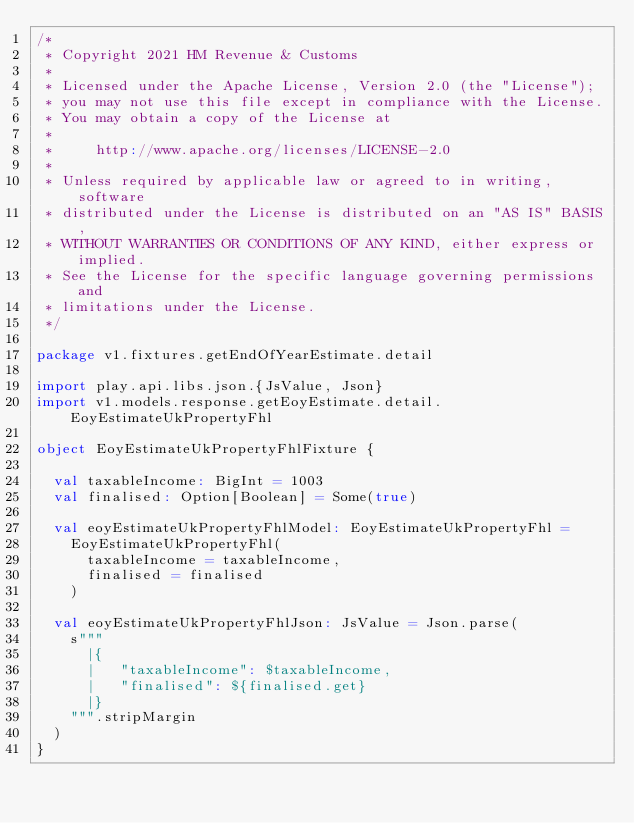Convert code to text. <code><loc_0><loc_0><loc_500><loc_500><_Scala_>/*
 * Copyright 2021 HM Revenue & Customs
 *
 * Licensed under the Apache License, Version 2.0 (the "License");
 * you may not use this file except in compliance with the License.
 * You may obtain a copy of the License at
 *
 *     http://www.apache.org/licenses/LICENSE-2.0
 *
 * Unless required by applicable law or agreed to in writing, software
 * distributed under the License is distributed on an "AS IS" BASIS,
 * WITHOUT WARRANTIES OR CONDITIONS OF ANY KIND, either express or implied.
 * See the License for the specific language governing permissions and
 * limitations under the License.
 */

package v1.fixtures.getEndOfYearEstimate.detail

import play.api.libs.json.{JsValue, Json}
import v1.models.response.getEoyEstimate.detail.EoyEstimateUkPropertyFhl

object EoyEstimateUkPropertyFhlFixture {

  val taxableIncome: BigInt = 1003
  val finalised: Option[Boolean] = Some(true)

  val eoyEstimateUkPropertyFhlModel: EoyEstimateUkPropertyFhl =
    EoyEstimateUkPropertyFhl(
      taxableIncome = taxableIncome,
      finalised = finalised
    )

  val eoyEstimateUkPropertyFhlJson: JsValue = Json.parse(
    s"""
      |{
      |   "taxableIncome": $taxableIncome,
      |   "finalised": ${finalised.get}
      |}
    """.stripMargin
  )
}</code> 